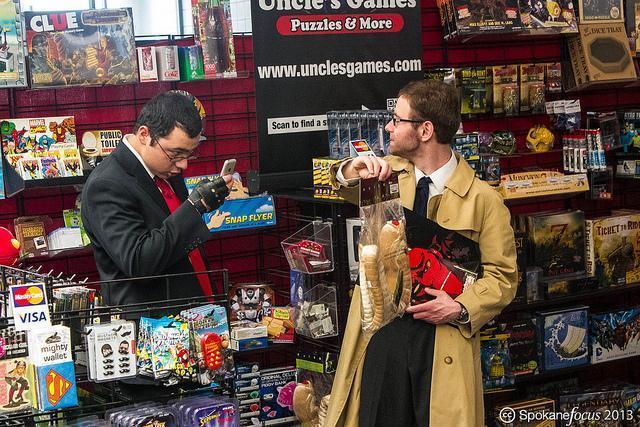How many people are there?
Give a very brief answer. 2. How many books can be seen?
Give a very brief answer. 3. How many bottle caps are in the photo?
Give a very brief answer. 0. 